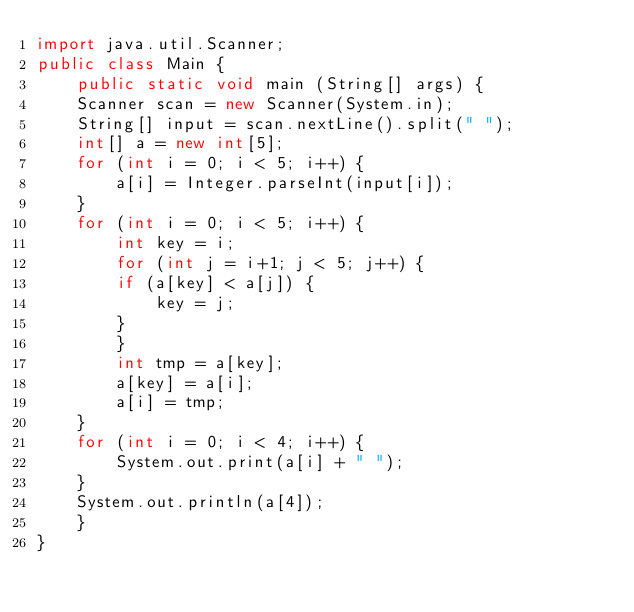Convert code to text. <code><loc_0><loc_0><loc_500><loc_500><_Java_>import java.util.Scanner;
public class Main {
    public static void main (String[] args) {
	Scanner scan = new Scanner(System.in);
	String[] input = scan.nextLine().split(" ");
	int[] a = new int[5];
	for (int i = 0; i < 5; i++) {
	    a[i] = Integer.parseInt(input[i]);
	}
	for (int i = 0; i < 5; i++) {
	    int key = i;
	    for (int j = i+1; j < 5; j++) {
		if (a[key] < a[j]) {
		    key = j;
		}
	    }
	    int tmp = a[key];
	    a[key] = a[i];
	    a[i] = tmp;
	}
	for (int i = 0; i < 4; i++) {
	    System.out.print(a[i] + " ");
	}
	System.out.println(a[4]);
    }
}</code> 